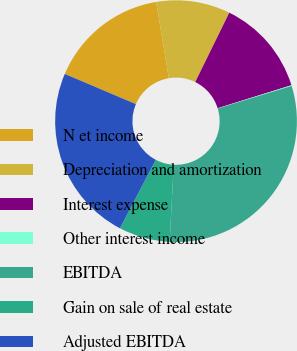Convert chart. <chart><loc_0><loc_0><loc_500><loc_500><pie_chart><fcel>N et income<fcel>Depreciation and amortization<fcel>Interest expense<fcel>Other interest income<fcel>EBITDA<fcel>Gain on sale of real estate<fcel>Adjusted EBITDA<nl><fcel>15.98%<fcel>9.89%<fcel>12.93%<fcel>0.1%<fcel>30.55%<fcel>6.84%<fcel>23.71%<nl></chart> 